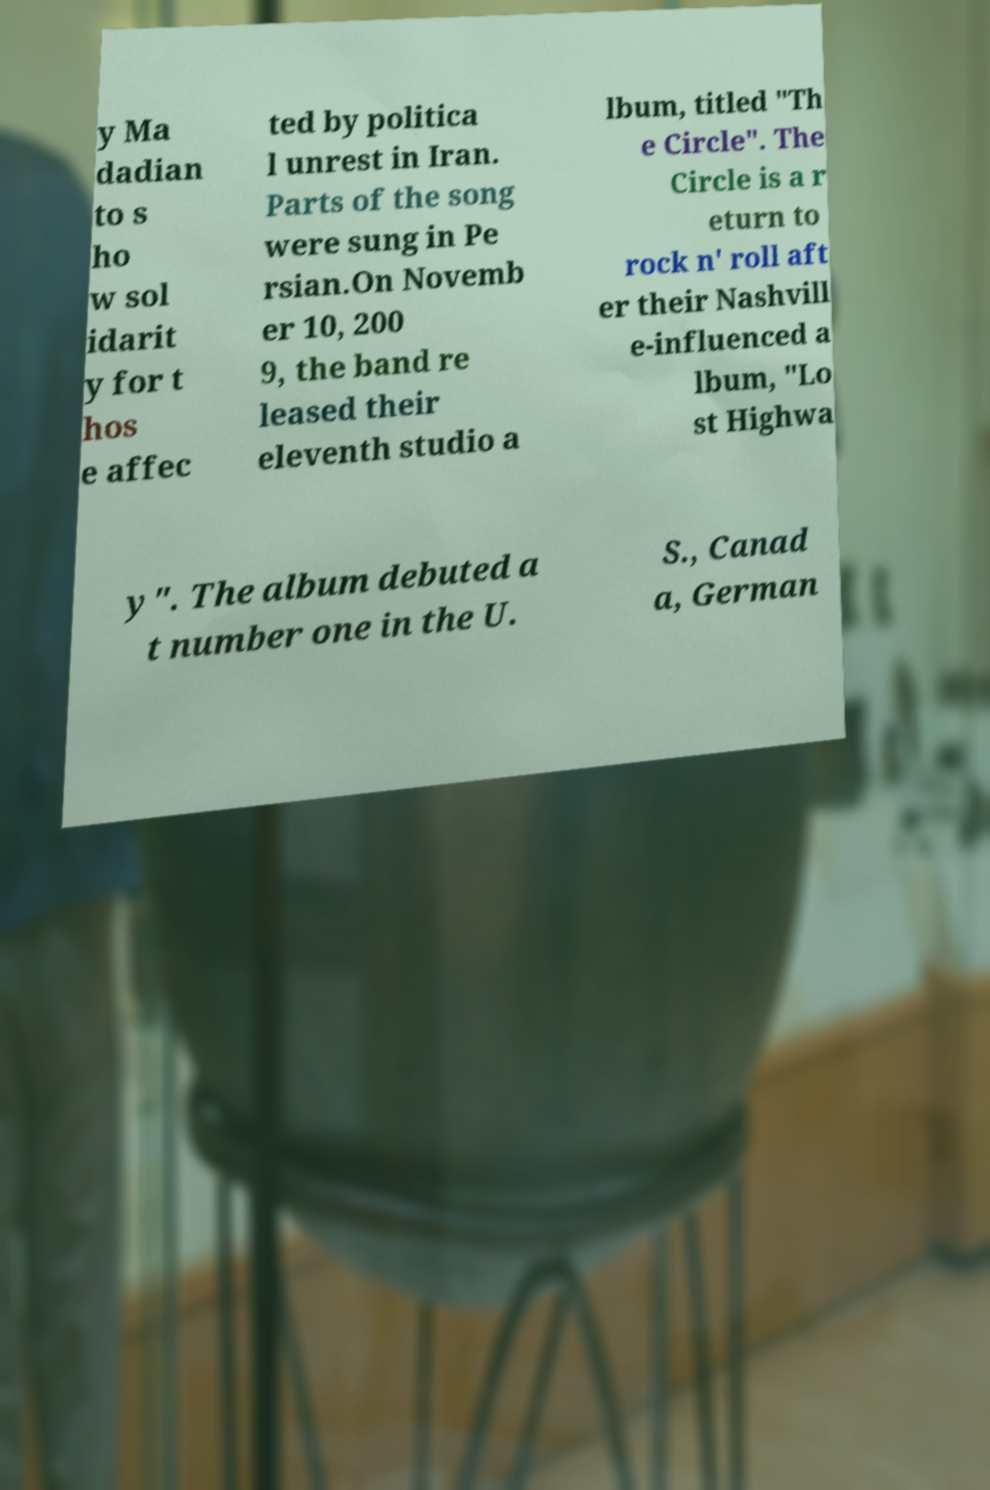I need the written content from this picture converted into text. Can you do that? y Ma dadian to s ho w sol idarit y for t hos e affec ted by politica l unrest in Iran. Parts of the song were sung in Pe rsian.On Novemb er 10, 200 9, the band re leased their eleventh studio a lbum, titled "Th e Circle". The Circle is a r eturn to rock n' roll aft er their Nashvill e-influenced a lbum, "Lo st Highwa y". The album debuted a t number one in the U. S., Canad a, German 